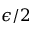Convert formula to latex. <formula><loc_0><loc_0><loc_500><loc_500>\epsilon / 2</formula> 